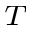Convert formula to latex. <formula><loc_0><loc_0><loc_500><loc_500>_ { T }</formula> 